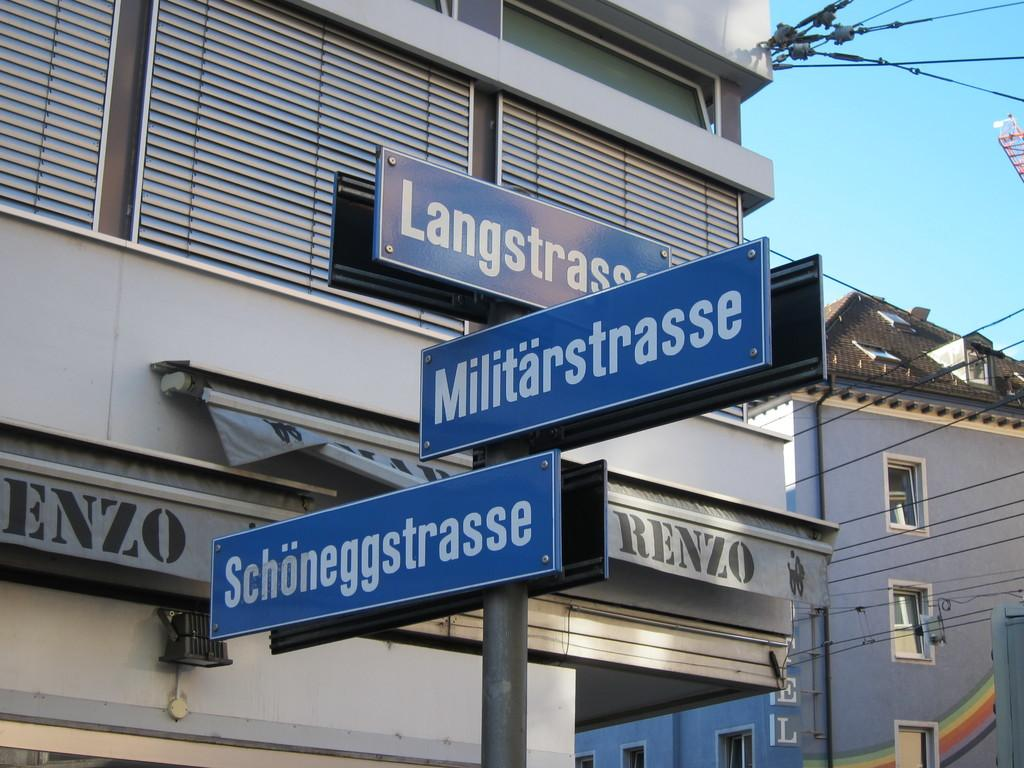What type of structures can be seen in the image? There are buildings in the image. What part of the natural environment is visible in the image? The sky is visible in the image. What objects are present in the image? There are boards and a pole in the image. What is written on the boards? Something is written on the boards. What type of breakfast is being served on the pole in the image? There is no breakfast or pole with food present in the image. Who is the governor mentioned on the boards in the image? There is no mention of a governor or any specific person on the boards in the image. 